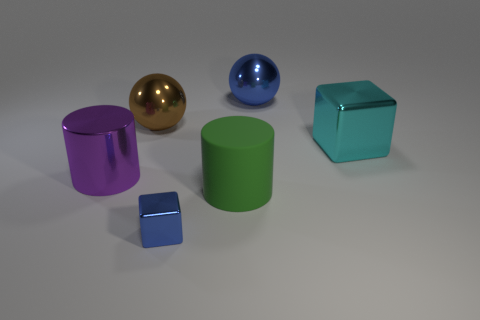There is a purple thing that is the same shape as the green thing; what size is it?
Your answer should be compact. Large. What color is the other small object that is the same shape as the cyan object?
Your response must be concise. Blue. What color is the shiny sphere in front of the sphere that is right of the green cylinder?
Keep it short and to the point. Brown. How many other objects are there of the same color as the tiny shiny cube?
Your answer should be very brief. 1. What number of things are large metallic things or big spheres to the right of the blue metallic block?
Ensure brevity in your answer.  4. There is a cylinder to the right of the purple cylinder; what color is it?
Offer a very short reply. Green. What shape is the purple object?
Give a very brief answer. Cylinder. What is the material of the blue thing left of the ball right of the tiny blue cube?
Offer a very short reply. Metal. How many other things are the same material as the purple cylinder?
Provide a succinct answer. 4. What is the material of the blue ball that is the same size as the purple cylinder?
Offer a terse response. Metal. 